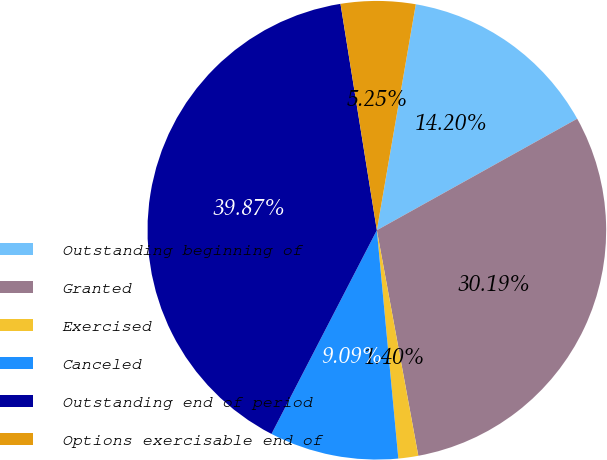<chart> <loc_0><loc_0><loc_500><loc_500><pie_chart><fcel>Outstanding beginning of<fcel>Granted<fcel>Exercised<fcel>Canceled<fcel>Outstanding end of period<fcel>Options exercisable end of<nl><fcel>14.2%<fcel>30.19%<fcel>1.4%<fcel>9.09%<fcel>39.87%<fcel>5.25%<nl></chart> 